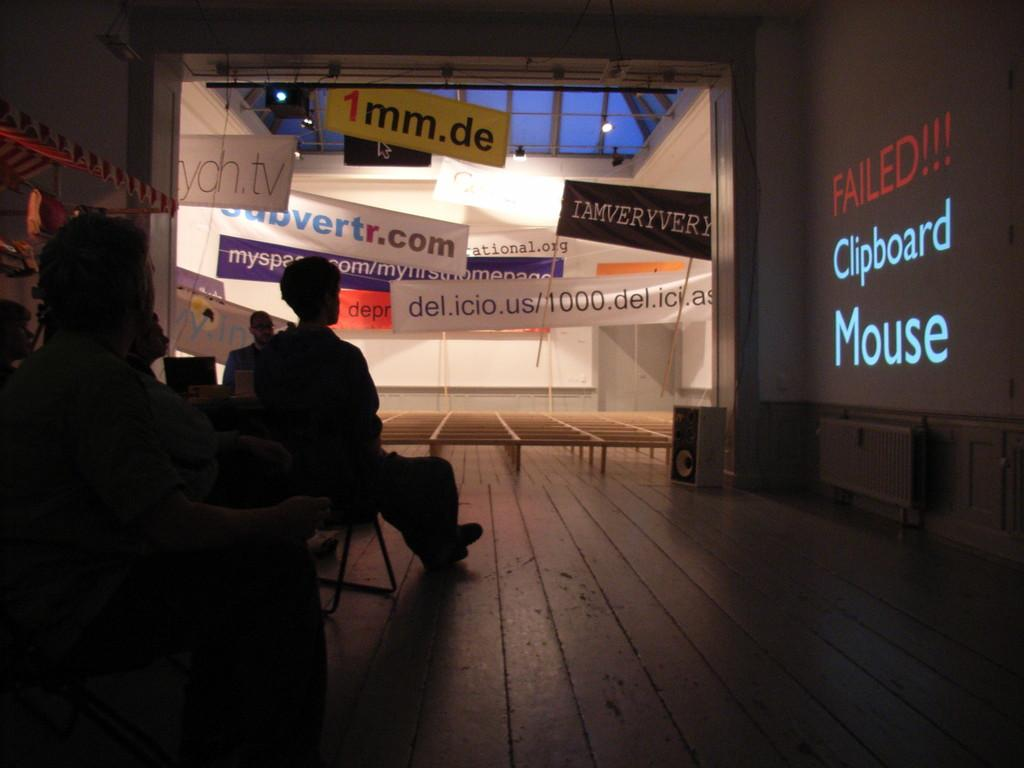What are the people in the image doing? The people in the image are sitting on chairs. What is on the wall in the image? There is a projector screen on the wall. What is on the glass window in the image? Banners are pasted on the glass window. What type of toothbrush is being used to control the projector in the image? There is no toothbrush or control of a projector depicted in the image. 